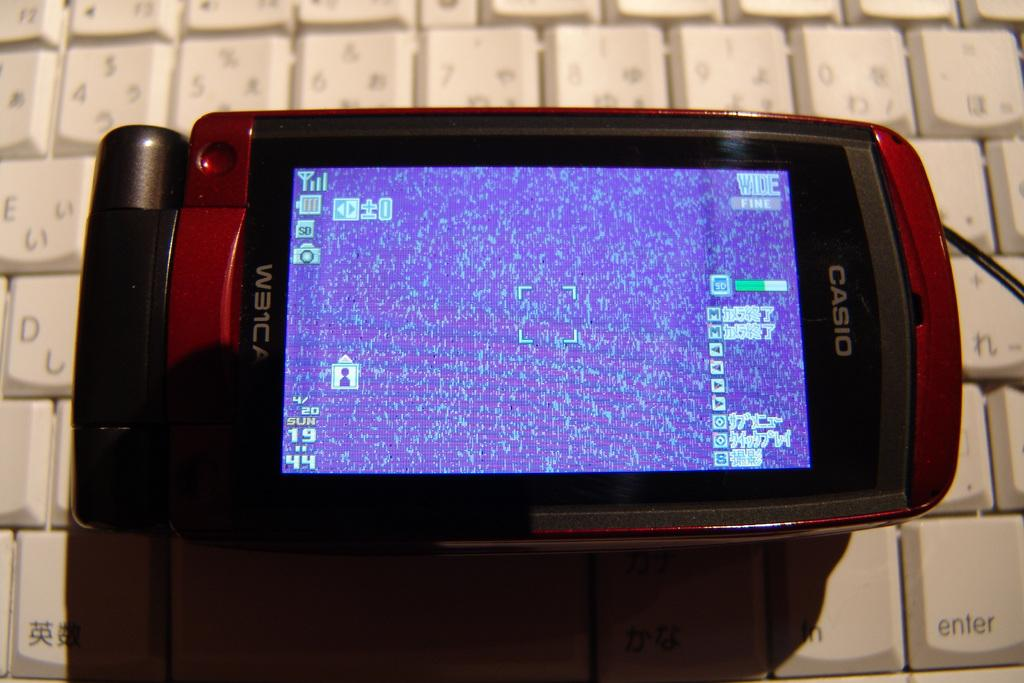What is the main object in the image? There is a mobile in the image. Where is the mobile located? The mobile is on a keyboard. How many boats can be seen in the image? There are no boats present in the image. What level of detail can be observed on the mobile in the image? The provided facts do not mention the level of detail on the mobile, so it cannot be determined from the image. 